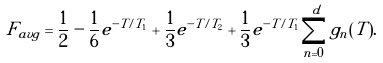<formula> <loc_0><loc_0><loc_500><loc_500>F _ { a v g } = \frac { 1 } { 2 } - \frac { 1 } { 6 } e ^ { - T / T _ { 1 } } + \frac { 1 } { 3 } e ^ { - T / T _ { 2 } } + \frac { 1 } { 3 } e ^ { - T / T _ { 1 } } \sum _ { n = 0 } ^ { d } g _ { n } ( T ) .</formula> 